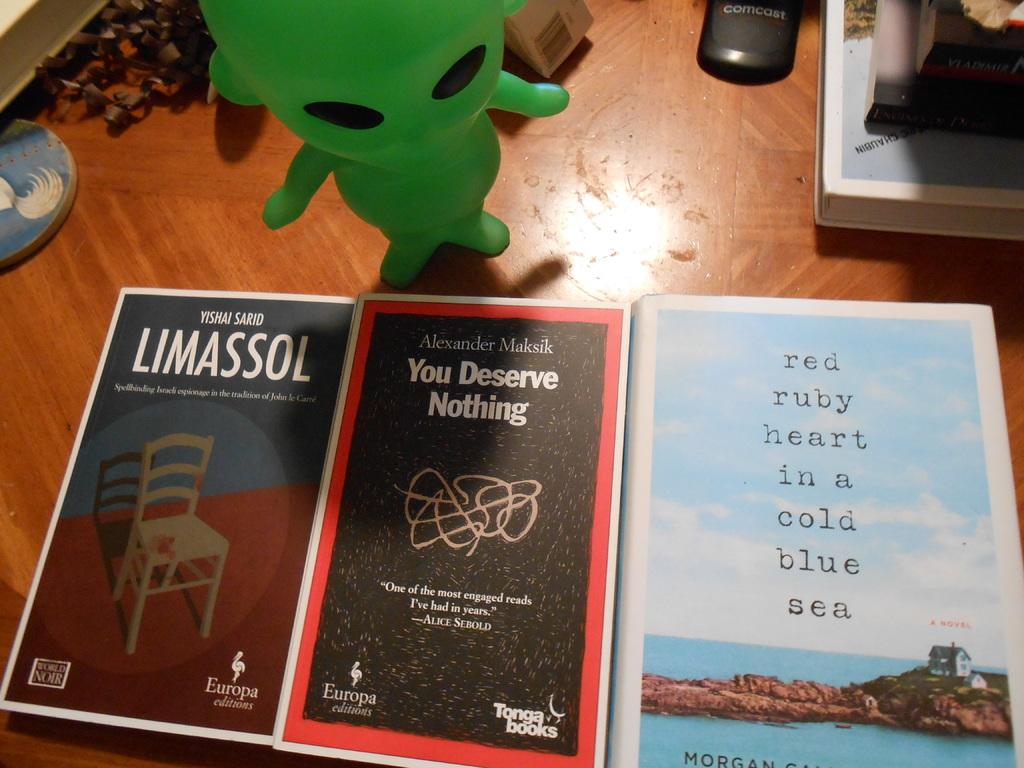What kind of sea is mentioned on the book to the right?
Ensure brevity in your answer.  Cold blue. 